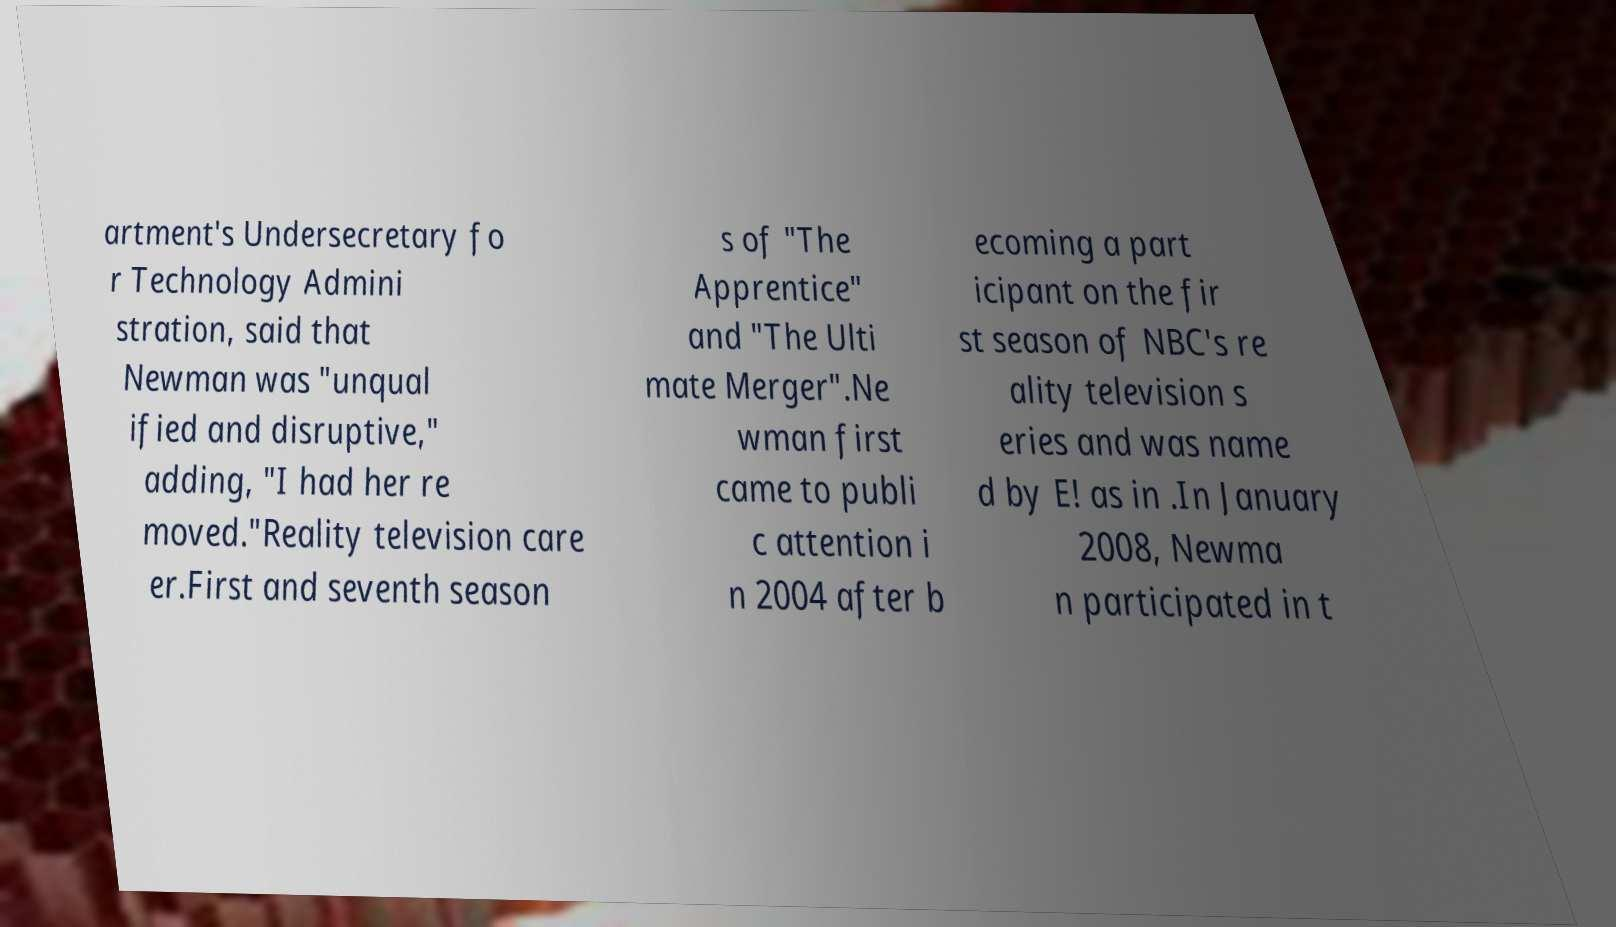Can you read and provide the text displayed in the image?This photo seems to have some interesting text. Can you extract and type it out for me? artment's Undersecretary fo r Technology Admini stration, said that Newman was "unqual ified and disruptive," adding, "I had her re moved."Reality television care er.First and seventh season s of "The Apprentice" and "The Ulti mate Merger".Ne wman first came to publi c attention i n 2004 after b ecoming a part icipant on the fir st season of NBC's re ality television s eries and was name d by E! as in .In January 2008, Newma n participated in t 